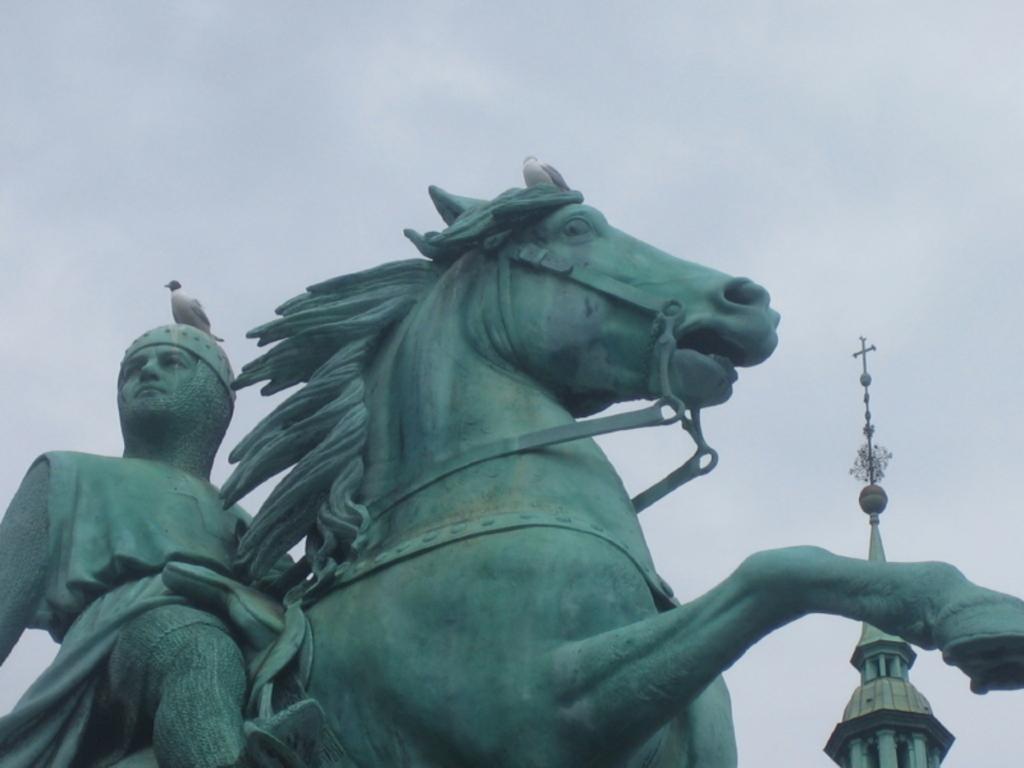Can you describe this image briefly? This image consists of a statue of a person and a horse. In the background, we can see a tower. At the top, there is a bird and there are clouds in the sky. 